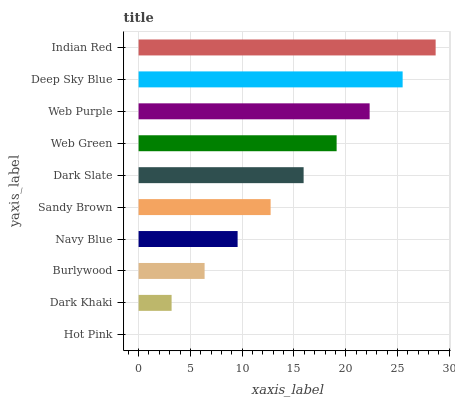Is Hot Pink the minimum?
Answer yes or no. Yes. Is Indian Red the maximum?
Answer yes or no. Yes. Is Dark Khaki the minimum?
Answer yes or no. No. Is Dark Khaki the maximum?
Answer yes or no. No. Is Dark Khaki greater than Hot Pink?
Answer yes or no. Yes. Is Hot Pink less than Dark Khaki?
Answer yes or no. Yes. Is Hot Pink greater than Dark Khaki?
Answer yes or no. No. Is Dark Khaki less than Hot Pink?
Answer yes or no. No. Is Dark Slate the high median?
Answer yes or no. Yes. Is Sandy Brown the low median?
Answer yes or no. Yes. Is Deep Sky Blue the high median?
Answer yes or no. No. Is Dark Khaki the low median?
Answer yes or no. No. 